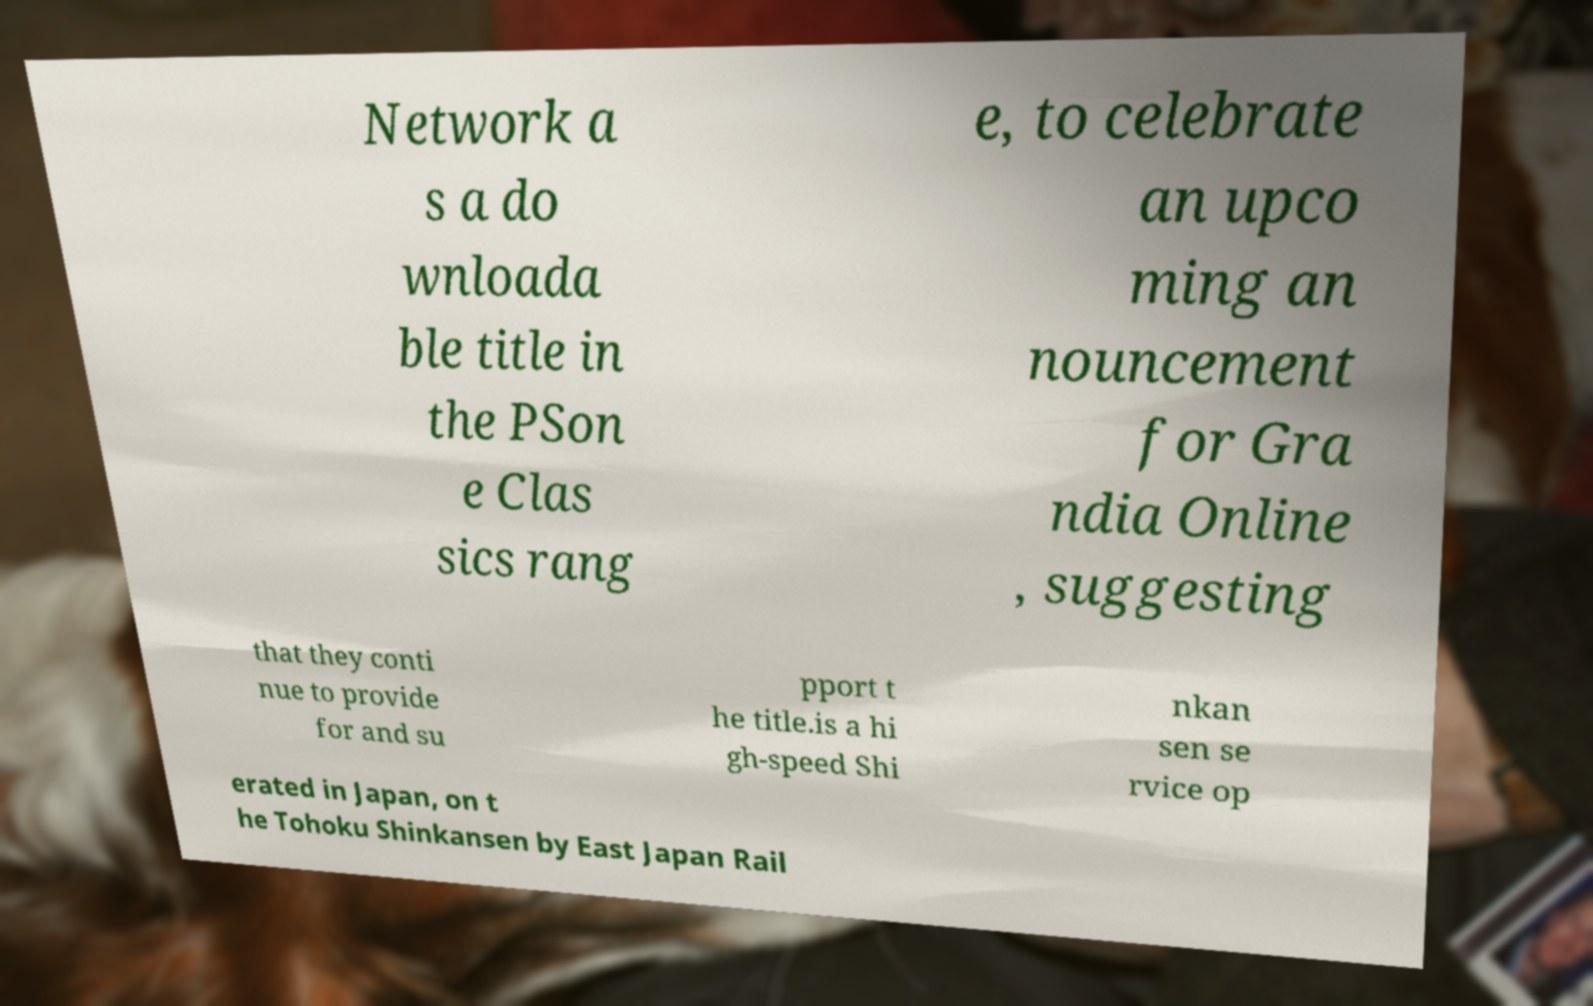Could you assist in decoding the text presented in this image and type it out clearly? Network a s a do wnloada ble title in the PSon e Clas sics rang e, to celebrate an upco ming an nouncement for Gra ndia Online , suggesting that they conti nue to provide for and su pport t he title.is a hi gh-speed Shi nkan sen se rvice op erated in Japan, on t he Tohoku Shinkansen by East Japan Rail 